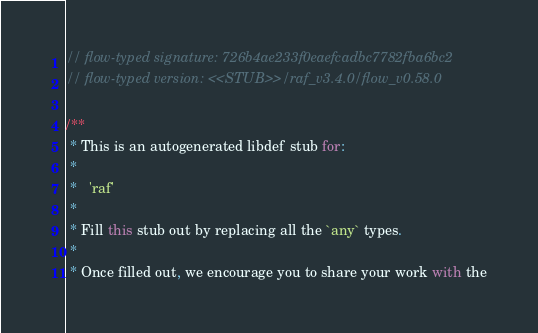Convert code to text. <code><loc_0><loc_0><loc_500><loc_500><_JavaScript_>// flow-typed signature: 726b4ae233f0eaefcadbc7782fba6bc2
// flow-typed version: <<STUB>>/raf_v3.4.0/flow_v0.58.0

/**
 * This is an autogenerated libdef stub for:
 *
 *   'raf'
 *
 * Fill this stub out by replacing all the `any` types.
 *
 * Once filled out, we encourage you to share your work with the</code> 